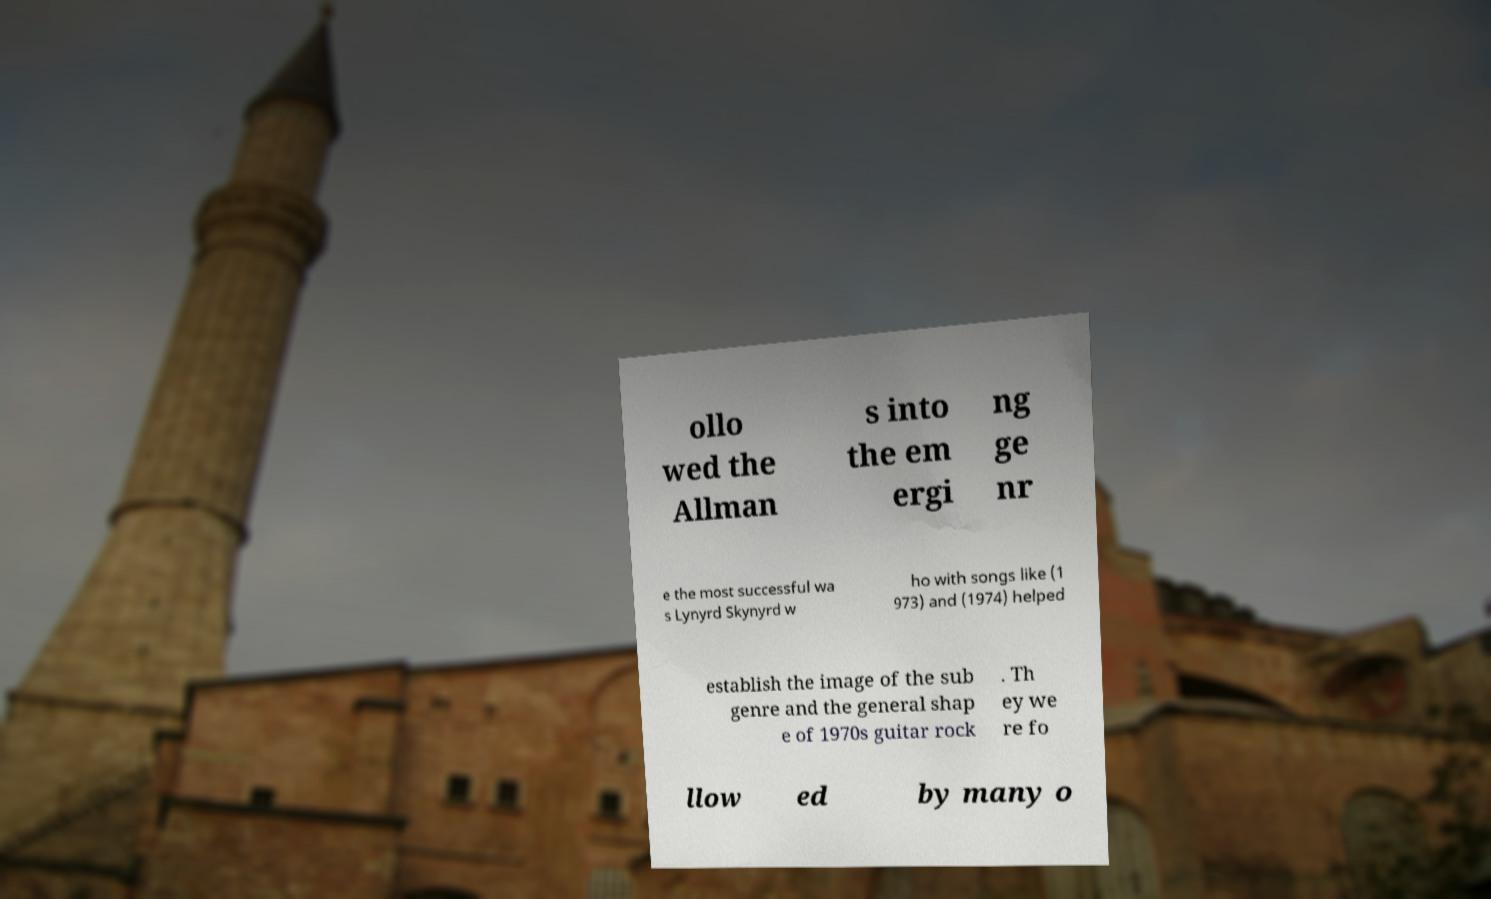For documentation purposes, I need the text within this image transcribed. Could you provide that? ollo wed the Allman s into the em ergi ng ge nr e the most successful wa s Lynyrd Skynyrd w ho with songs like (1 973) and (1974) helped establish the image of the sub genre and the general shap e of 1970s guitar rock . Th ey we re fo llow ed by many o 